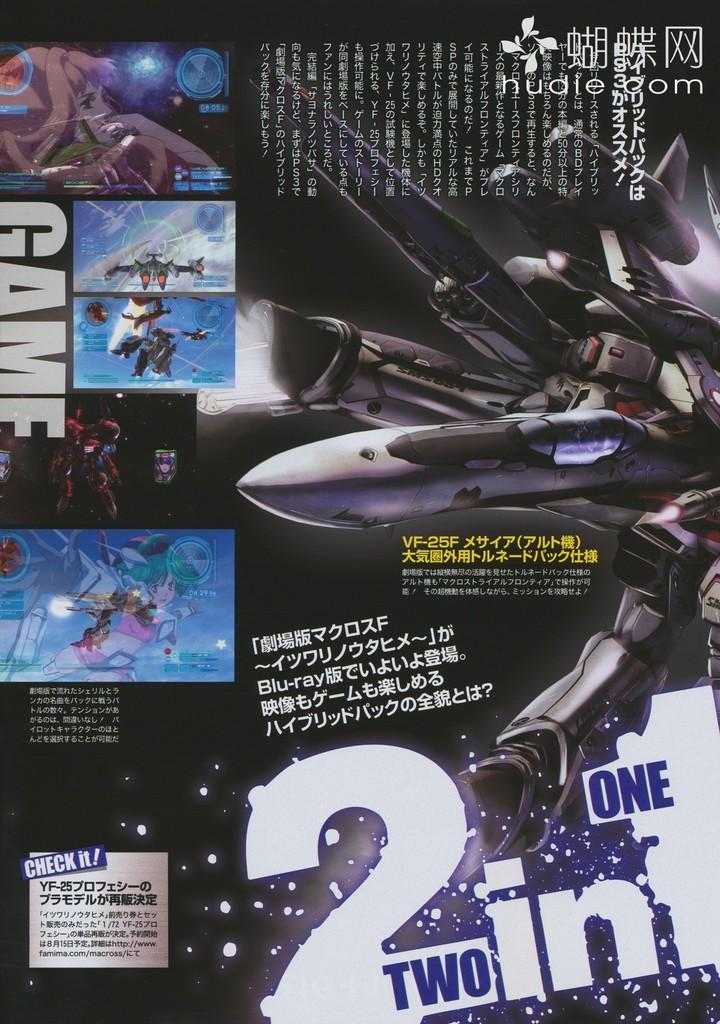<image>
Share a concise interpretation of the image provided. An ad for a game has a large number 2 on it. 